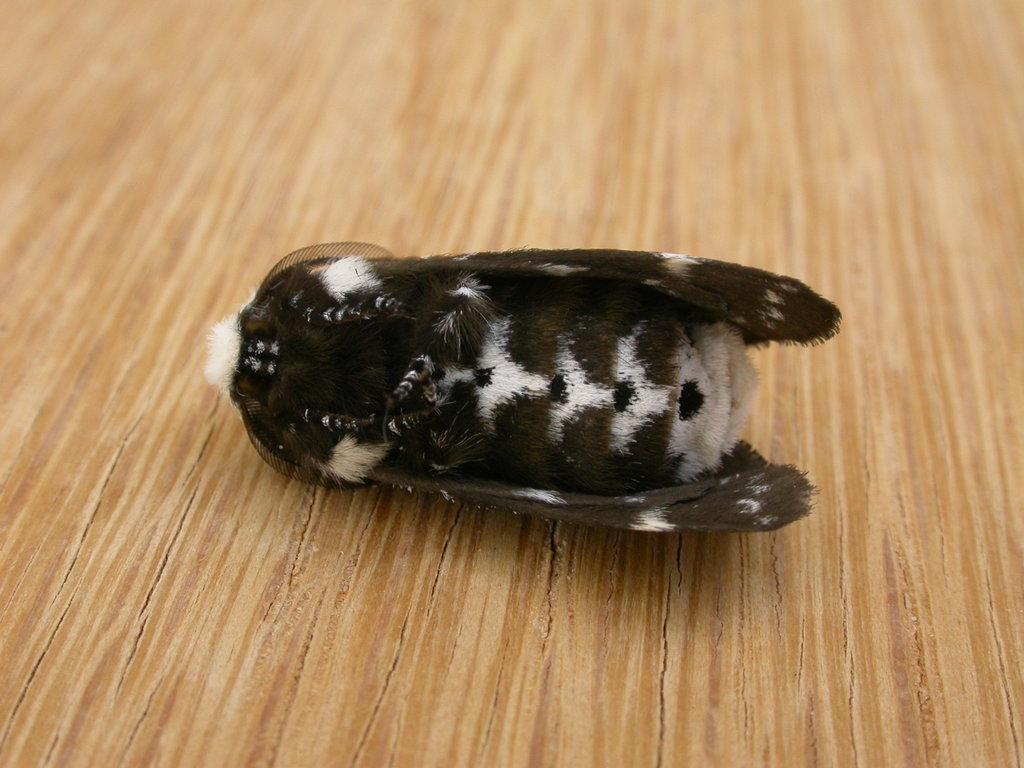Can you describe this image briefly? We can see insect on the wooden surface. 